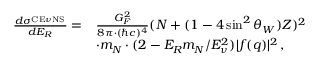<formula> <loc_0><loc_0><loc_500><loc_500>\begin{array} { r l } { \frac { d \sigma ^ { _ { C E \nu N S } } } { d E _ { R } } = } & { \frac { G _ { F } ^ { 2 } } { 8 \pi \cdot ( \hbar { c } ) ^ { 4 } } ( N + ( 1 - 4 \sin ^ { 2 } \theta _ { W } ) Z ) ^ { 2 } } \\ & { \cdot m _ { N } \cdot ( 2 - E _ { R } m _ { N } / E _ { \nu } ^ { 2 } ) | f ( q ) | ^ { 2 } \, , } \end{array}</formula> 